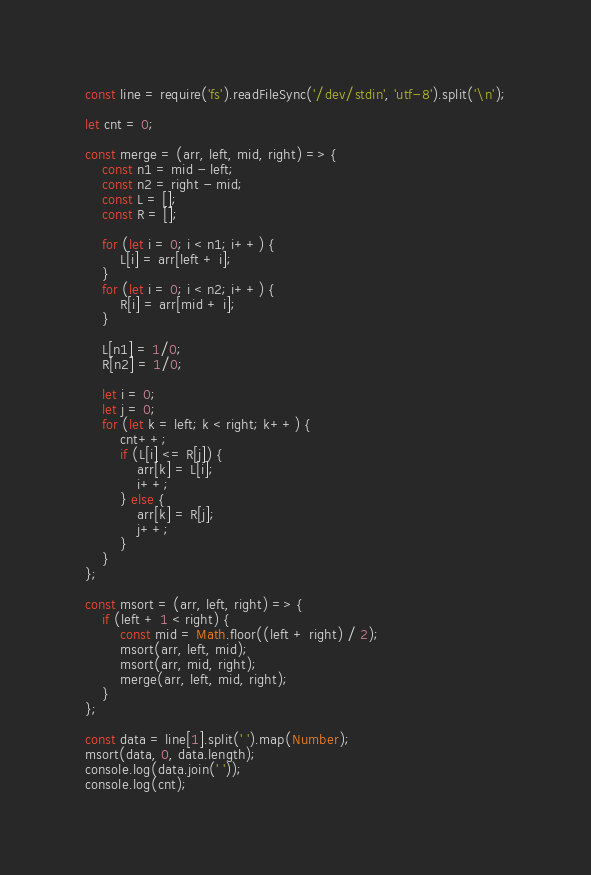<code> <loc_0><loc_0><loc_500><loc_500><_JavaScript_>const line = require('fs').readFileSync('/dev/stdin', 'utf-8').split('\n');

let cnt = 0;

const merge = (arr, left, mid, right) => {
    const n1 = mid - left;
    const n2 = right - mid;
    const L = [];
    const R = [];

    for (let i = 0; i < n1; i++) {
        L[i] = arr[left + i];
    }
    for (let i = 0; i < n2; i++) {
        R[i] = arr[mid + i];
    }

    L[n1] = 1/0;
    R[n2] = 1/0;

    let i = 0;
    let j = 0;
    for (let k = left; k < right; k++) {
        cnt++;
        if (L[i] <= R[j]) {
            arr[k] = L[i];
            i++;
        } else {
            arr[k] = R[j];
            j++;
        }
    }
};

const msort = (arr, left, right) => {
    if (left + 1 < right) {
        const mid = Math.floor((left + right) / 2);
        msort(arr, left, mid);
        msort(arr, mid, right);
        merge(arr, left, mid, right);
    }
};

const data = line[1].split(' ').map(Number);
msort(data, 0, data.length);
console.log(data.join(' '));
console.log(cnt);

</code> 